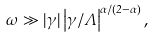Convert formula to latex. <formula><loc_0><loc_0><loc_500><loc_500>\omega \gg | \gamma | \left | \gamma / \Lambda \right | ^ { \alpha / ( 2 - \alpha ) } ,</formula> 